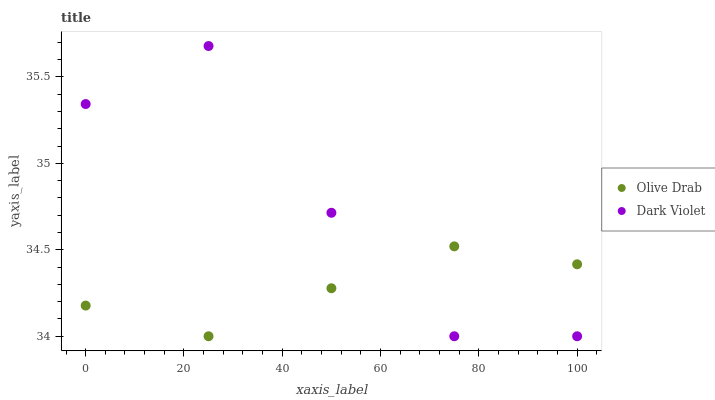Does Olive Drab have the minimum area under the curve?
Answer yes or no. Yes. Does Dark Violet have the maximum area under the curve?
Answer yes or no. Yes. Does Olive Drab have the maximum area under the curve?
Answer yes or no. No. Is Olive Drab the smoothest?
Answer yes or no. Yes. Is Dark Violet the roughest?
Answer yes or no. Yes. Is Olive Drab the roughest?
Answer yes or no. No. Does Dark Violet have the lowest value?
Answer yes or no. Yes. Does Dark Violet have the highest value?
Answer yes or no. Yes. Does Olive Drab have the highest value?
Answer yes or no. No. Does Olive Drab intersect Dark Violet?
Answer yes or no. Yes. Is Olive Drab less than Dark Violet?
Answer yes or no. No. Is Olive Drab greater than Dark Violet?
Answer yes or no. No. 